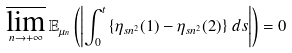<formula> <loc_0><loc_0><loc_500><loc_500>\varlimsup _ { n \to + \infty } \mathbb { E } _ { \mu _ { n } } \left ( \left | \int _ { 0 } ^ { t } \left \{ \eta _ { s n ^ { 2 } } ( 1 ) - \eta _ { s n ^ { 2 } } ( 2 ) \right \} \, d s \right | \right ) = 0</formula> 